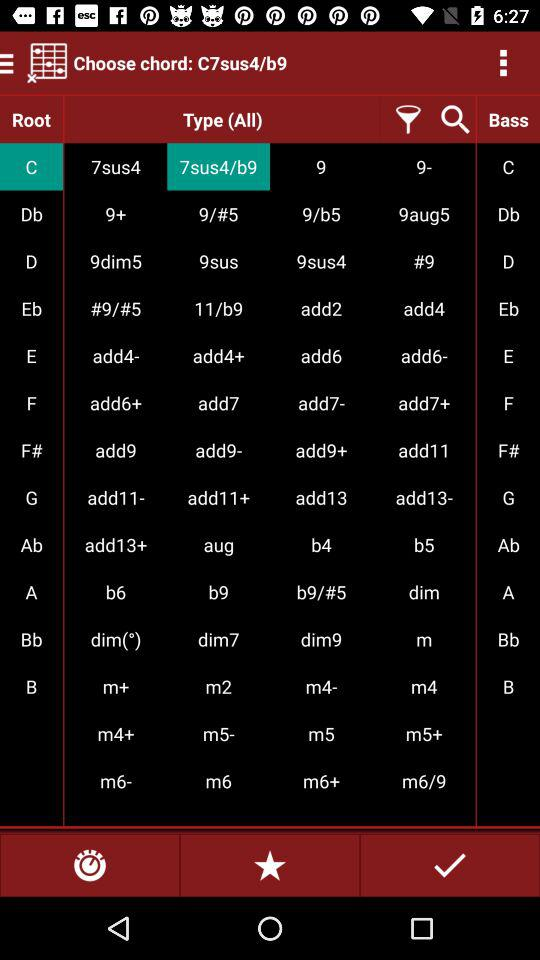Which root note is selected? The selected root note is "C". 